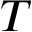Convert formula to latex. <formula><loc_0><loc_0><loc_500><loc_500>T</formula> 